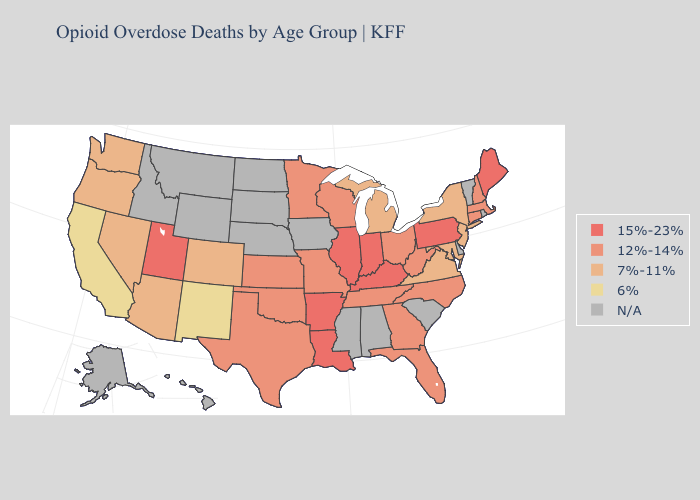Among the states that border Ohio , does Kentucky have the highest value?
Answer briefly. Yes. What is the highest value in states that border Texas?
Quick response, please. 15%-23%. Name the states that have a value in the range 15%-23%?
Be succinct. Arkansas, Illinois, Indiana, Kentucky, Louisiana, Maine, Pennsylvania, Utah. Which states hav the highest value in the South?
Keep it brief. Arkansas, Kentucky, Louisiana. What is the value of Louisiana?
Write a very short answer. 15%-23%. What is the value of Kentucky?
Short answer required. 15%-23%. Among the states that border Delaware , does Maryland have the lowest value?
Answer briefly. Yes. Which states hav the highest value in the South?
Concise answer only. Arkansas, Kentucky, Louisiana. Is the legend a continuous bar?
Write a very short answer. No. What is the value of Ohio?
Write a very short answer. 12%-14%. Does Pennsylvania have the highest value in the Northeast?
Answer briefly. Yes. What is the lowest value in the South?
Answer briefly. 7%-11%. Among the states that border South Carolina , which have the lowest value?
Short answer required. Georgia, North Carolina. What is the value of Vermont?
Answer briefly. N/A. 